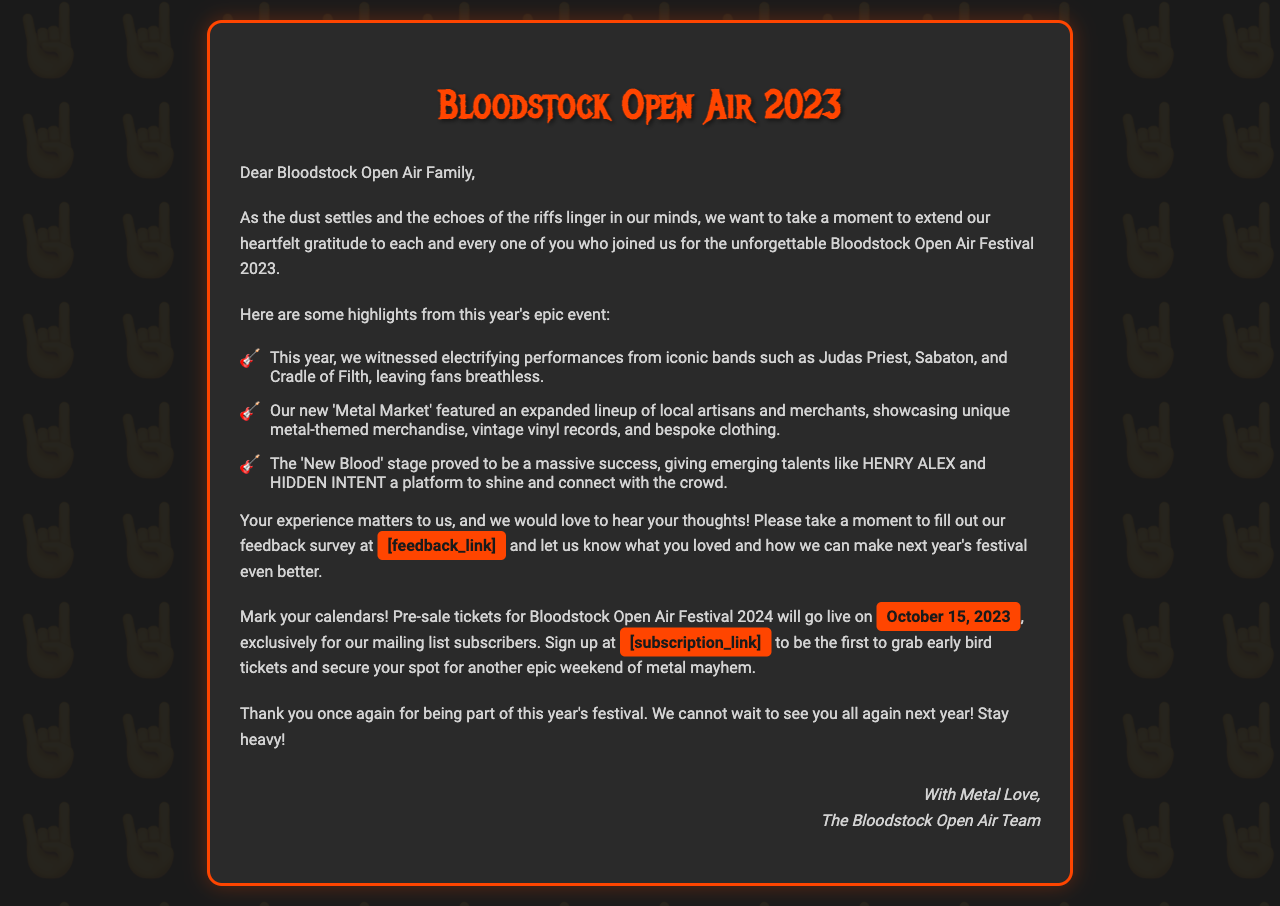what is the title of the event? The title of the event is stated at the beginning of the letter.
Answer: Bloodstock Open Air 2023 who were the iconic bands mentioned in the highlights? The letter lists specific bands that performed at the festival as highlights.
Answer: Judas Priest, Sabaton, Cradle of Filth what date do pre-sale tickets go live? The document specifies the exact date when pre-sale tickets will become available.
Answer: October 15, 2023 what is the link for the feedback survey? The document refers to a designated place for attendees to provide their feedback but does not provide a specific URL.
Answer: [feedback_link] what is emphasized as a significant feature in this year's festival? The text highlights a specific new addition that was part of this year's festival.
Answer: Metal Market what does the letter invite attendees to do? The letter suggests a specific action for attendees regarding their experience at the festival.
Answer: Fill out our feedback survey who signs off the letter? The closing of the document reveals the signers of the letter.
Answer: The Bloodstock Open Air Team which bands were featured on the 'New Blood' stage? The letter mentions specific emerging talents that performed on this stage.
Answer: HENRY ALEX, HIDDEN INTENT what phrase conveys the organizers' appreciation for the attendees? There is a phrase in the document that captures the gratitude expressed towards the attendees.
Answer: heartfelt gratitude 